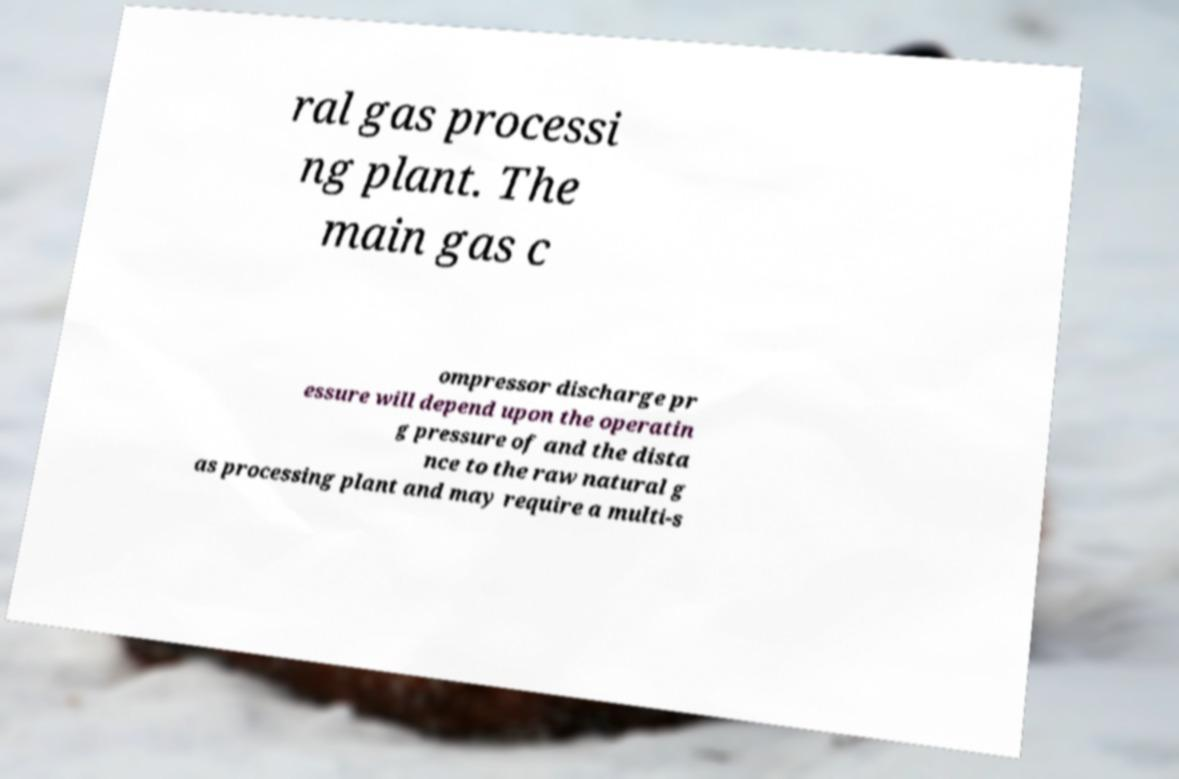Could you extract and type out the text from this image? ral gas processi ng plant. The main gas c ompressor discharge pr essure will depend upon the operatin g pressure of and the dista nce to the raw natural g as processing plant and may require a multi-s 